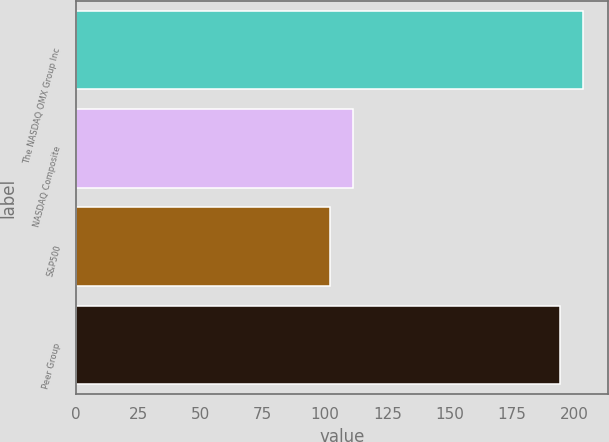<chart> <loc_0><loc_0><loc_500><loc_500><bar_chart><fcel>The NASDAQ OMX Group Inc<fcel>NASDAQ Composite<fcel>S&P500<fcel>Peer Group<nl><fcel>203.39<fcel>111.33<fcel>102.11<fcel>194.17<nl></chart> 